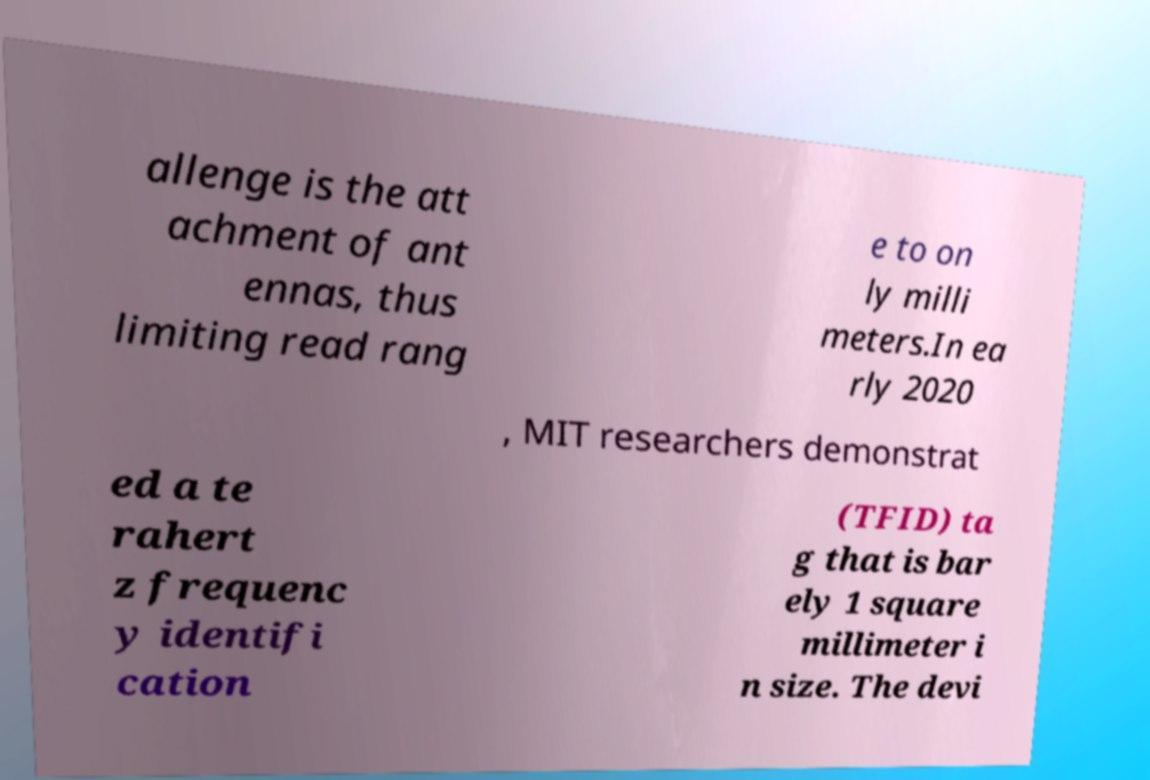What messages or text are displayed in this image? I need them in a readable, typed format. allenge is the att achment of ant ennas, thus limiting read rang e to on ly milli meters.In ea rly 2020 , MIT researchers demonstrat ed a te rahert z frequenc y identifi cation (TFID) ta g that is bar ely 1 square millimeter i n size. The devi 